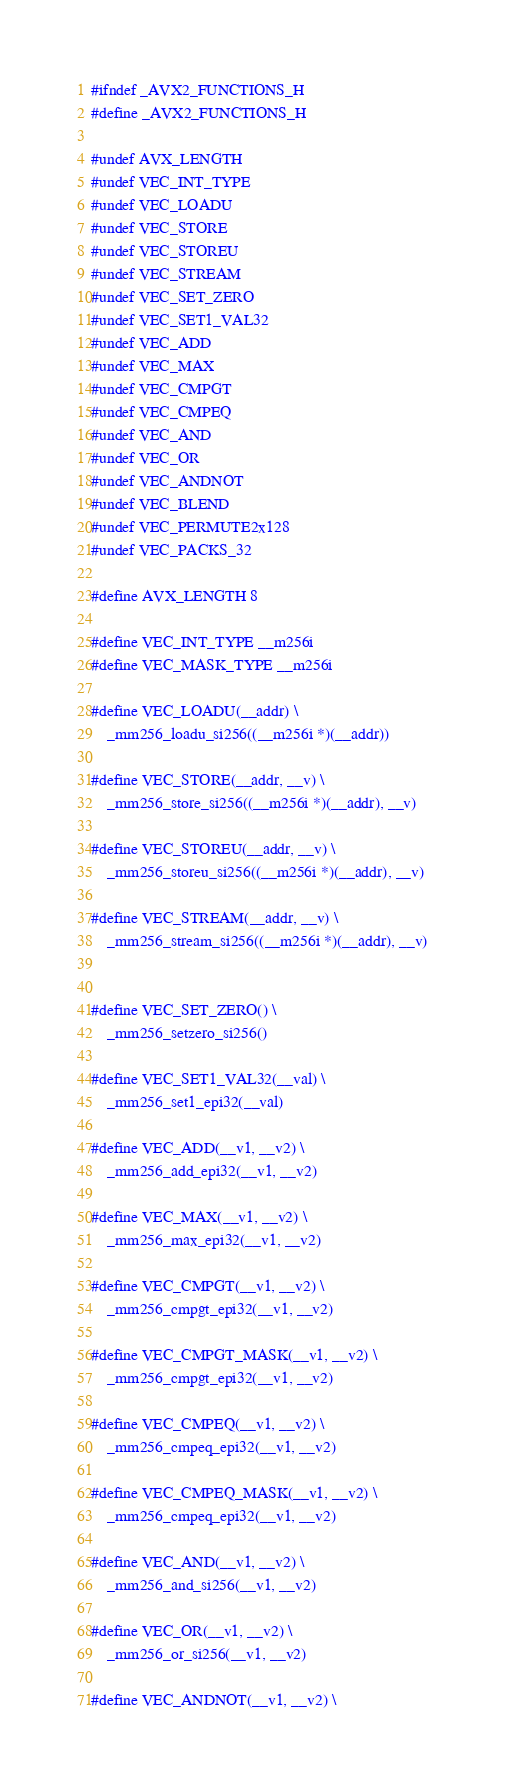Convert code to text. <code><loc_0><loc_0><loc_500><loc_500><_C_>#ifndef _AVX2_FUNCTIONS_H
#define _AVX2_FUNCTIONS_H

#undef AVX_LENGTH
#undef VEC_INT_TYPE
#undef VEC_LOADU
#undef VEC_STORE
#undef VEC_STOREU
#undef VEC_STREAM
#undef VEC_SET_ZERO
#undef VEC_SET1_VAL32
#undef VEC_ADD
#undef VEC_MAX
#undef VEC_CMPGT
#undef VEC_CMPEQ
#undef VEC_AND
#undef VEC_OR
#undef VEC_ANDNOT
#undef VEC_BLEND
#undef VEC_PERMUTE2x128
#undef VEC_PACKS_32

#define AVX_LENGTH 8

#define VEC_INT_TYPE __m256i
#define VEC_MASK_TYPE __m256i

#define VEC_LOADU(__addr) \
    _mm256_loadu_si256((__m256i *)(__addr))

#define VEC_STORE(__addr, __v) \
    _mm256_store_si256((__m256i *)(__addr), __v)

#define VEC_STOREU(__addr, __v) \
    _mm256_storeu_si256((__m256i *)(__addr), __v)

#define VEC_STREAM(__addr, __v) \
    _mm256_stream_si256((__m256i *)(__addr), __v)


#define VEC_SET_ZERO() \
    _mm256_setzero_si256()

#define VEC_SET1_VAL32(__val) \
    _mm256_set1_epi32(__val)

#define VEC_ADD(__v1, __v2) \
    _mm256_add_epi32(__v1, __v2)

#define VEC_MAX(__v1, __v2) \
    _mm256_max_epi32(__v1, __v2)
    
#define VEC_CMPGT(__v1, __v2) \
    _mm256_cmpgt_epi32(__v1, __v2)

#define VEC_CMPGT_MASK(__v1, __v2) \
    _mm256_cmpgt_epi32(__v1, __v2)

#define VEC_CMPEQ(__v1, __v2) \
    _mm256_cmpeq_epi32(__v1, __v2)

#define VEC_CMPEQ_MASK(__v1, __v2) \
    _mm256_cmpeq_epi32(__v1, __v2)

#define VEC_AND(__v1, __v2) \
    _mm256_and_si256(__v1, __v2)

#define VEC_OR(__v1, __v2) \
    _mm256_or_si256(__v1, __v2)

#define VEC_ANDNOT(__v1, __v2) \</code> 